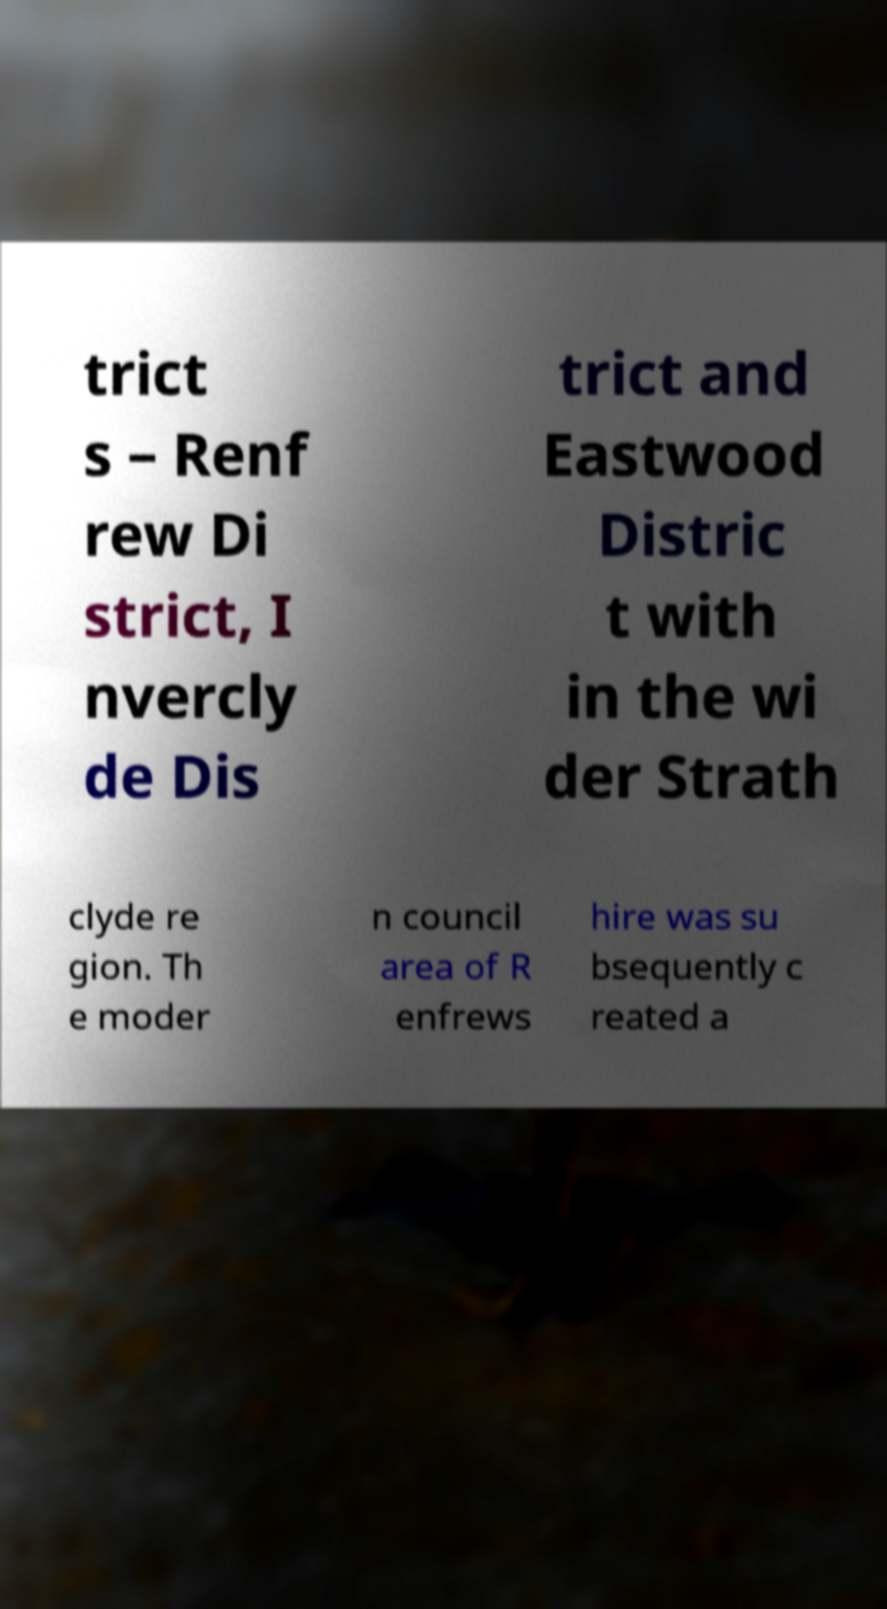Can you read and provide the text displayed in the image?This photo seems to have some interesting text. Can you extract and type it out for me? trict s – Renf rew Di strict, I nvercly de Dis trict and Eastwood Distric t with in the wi der Strath clyde re gion. Th e moder n council area of R enfrews hire was su bsequently c reated a 